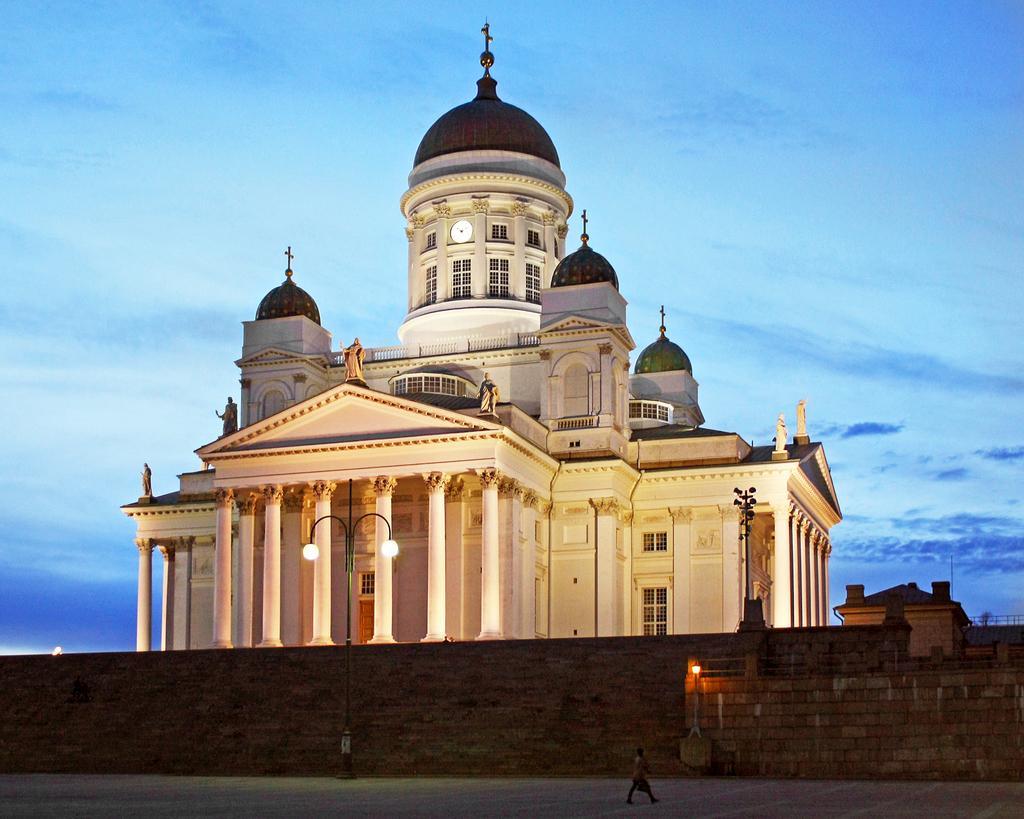In one or two sentences, can you explain what this image depicts? In this image there is a man walking on a road, in the background there is a light pole, wall, palace and the sky. 